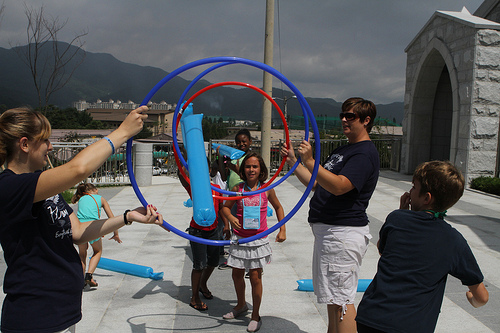<image>
Is there a hoop on the woman? No. The hoop is not positioned on the woman. They may be near each other, but the hoop is not supported by or resting on top of the woman. Is there a girl behind the hula hoop? Yes. From this viewpoint, the girl is positioned behind the hula hoop, with the hula hoop partially or fully occluding the girl. Is there a blowup next to the ring? No. The blowup is not positioned next to the ring. They are located in different areas of the scene. Where is the girl in relation to the circle? Is it in front of the circle? No. The girl is not in front of the circle. The spatial positioning shows a different relationship between these objects. 